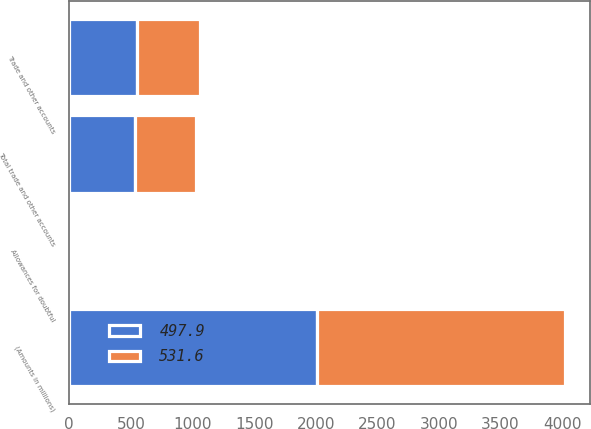Convert chart. <chart><loc_0><loc_0><loc_500><loc_500><stacked_bar_chart><ecel><fcel>(Amounts in millions)<fcel>Trade and other accounts<fcel>Allowances for doubtful<fcel>Total trade and other accounts<nl><fcel>497.9<fcel>2013<fcel>546.5<fcel>14.9<fcel>531.6<nl><fcel>531.6<fcel>2012<fcel>516.9<fcel>19<fcel>497.9<nl></chart> 